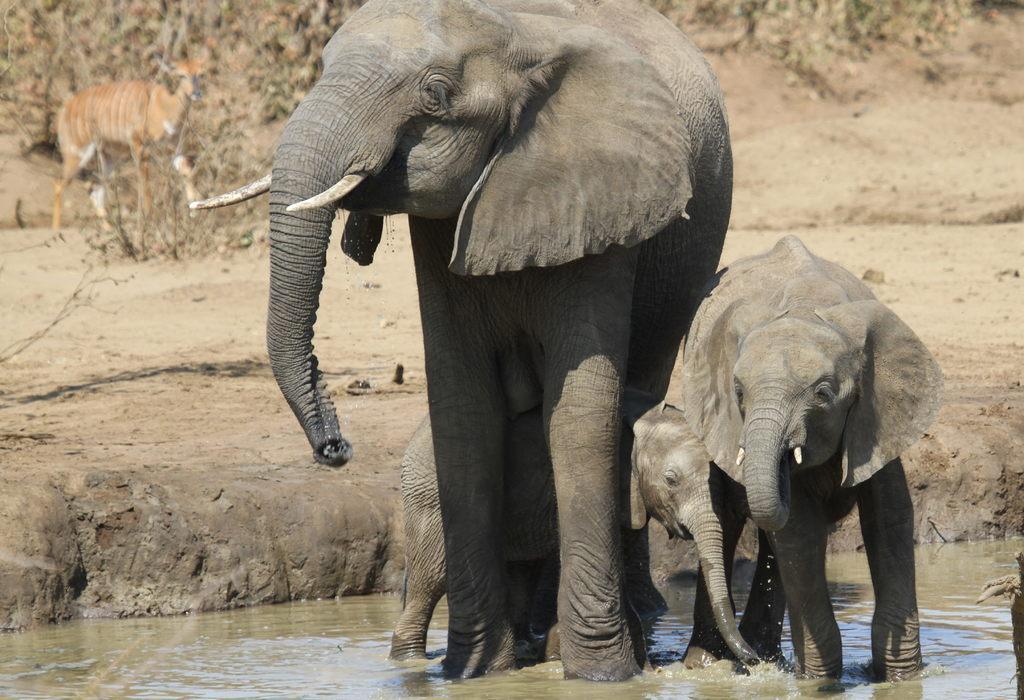Can you describe this image briefly? In this image we can see some elephants and calves which are in water and in the background of the image there is deer and some plants. 